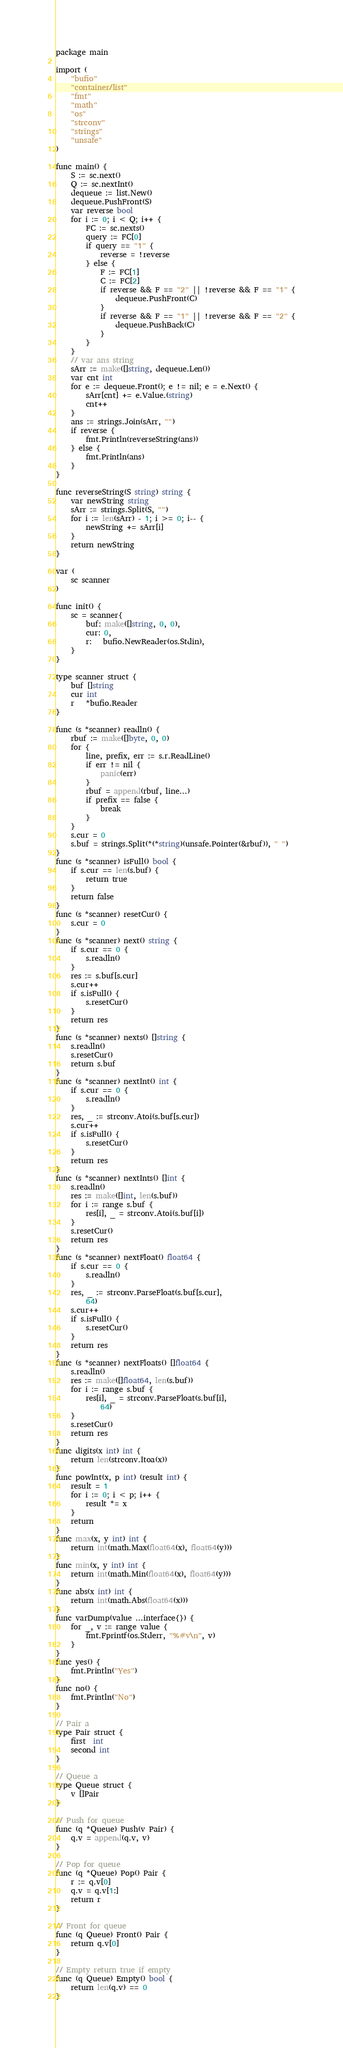<code> <loc_0><loc_0><loc_500><loc_500><_Go_>package main

import (
	"bufio"
	"container/list"
	"fmt"
	"math"
	"os"
	"strconv"
	"strings"
	"unsafe"
)

func main() {
	S := sc.next()
	Q := sc.nextInt()
	dequeue := list.New()
	dequeue.PushFront(S)
	var reverse bool
	for i := 0; i < Q; i++ {
		FC := sc.nexts()
		query := FC[0]
		if query == "1" {
			reverse = !reverse
		} else {
			F := FC[1]
			C := FC[2]
			if reverse && F == "2" || !reverse && F == "1" {
				dequeue.PushFront(C)
			}
			if reverse && F == "1" || !reverse && F == "2" {
				dequeue.PushBack(C)
			}
		}
	}
	// var ans string
	sArr := make([]string, dequeue.Len())
	var cnt int
	for e := dequeue.Front(); e != nil; e = e.Next() {
		sArr[cnt] += e.Value.(string)
		cnt++
	}
	ans := strings.Join(sArr, "")
	if reverse {
		fmt.Println(reverseString(ans))
	} else {
		fmt.Println(ans)
	}
}

func reverseString(S string) string {
	var newString string
	sArr := strings.Split(S, "")
	for i := len(sArr) - 1; i >= 0; i-- {
		newString += sArr[i]
	}
	return newString
}

var (
	sc scanner
)

func init() {
	sc = scanner{
		buf: make([]string, 0, 0),
		cur: 0,
		r:   bufio.NewReader(os.Stdin),
	}
}

type scanner struct {
	buf []string
	cur int
	r   *bufio.Reader
}

func (s *scanner) readln() {
	rbuf := make([]byte, 0, 0)
	for {
		line, prefix, err := s.r.ReadLine()
		if err != nil {
			panic(err)
		}
		rbuf = append(rbuf, line...)
		if prefix == false {
			break
		}
	}
	s.cur = 0
	s.buf = strings.Split(*(*string)(unsafe.Pointer(&rbuf)), " ")
}
func (s *scanner) isFull() bool {
	if s.cur == len(s.buf) {
		return true
	}
	return false
}
func (s *scanner) resetCur() {
	s.cur = 0
}
func (s *scanner) next() string {
	if s.cur == 0 {
		s.readln()
	}
	res := s.buf[s.cur]
	s.cur++
	if s.isFull() {
		s.resetCur()
	}
	return res
}
func (s *scanner) nexts() []string {
	s.readln()
	s.resetCur()
	return s.buf
}
func (s *scanner) nextInt() int {
	if s.cur == 0 {
		s.readln()
	}
	res, _ := strconv.Atoi(s.buf[s.cur])
	s.cur++
	if s.isFull() {
		s.resetCur()
	}
	return res
}
func (s *scanner) nextInts() []int {
	s.readln()
	res := make([]int, len(s.buf))
	for i := range s.buf {
		res[i], _ = strconv.Atoi(s.buf[i])
	}
	s.resetCur()
	return res
}
func (s *scanner) nextFloat() float64 {
	if s.cur == 0 {
		s.readln()
	}
	res, _ := strconv.ParseFloat(s.buf[s.cur],
		64)
	s.cur++
	if s.isFull() {
		s.resetCur()
	}
	return res
}
func (s *scanner) nextFloats() []float64 {
	s.readln()
	res := make([]float64, len(s.buf))
	for i := range s.buf {
		res[i], _ = strconv.ParseFloat(s.buf[i],
			64)
	}
	s.resetCur()
	return res
}
func digits(x int) int {
	return len(strconv.Itoa(x))
}
func powInt(x, p int) (result int) {
	result = 1
	for i := 0; i < p; i++ {
		result *= x
	}
	return
}
func max(x, y int) int {
	return int(math.Max(float64(x), float64(y)))
}
func min(x, y int) int {
	return int(math.Min(float64(x), float64(y)))
}
func abs(x int) int {
	return int(math.Abs(float64(x)))
}
func varDump(value ...interface{}) {
	for _, v := range value {
		fmt.Fprintf(os.Stderr, "%#v\n", v)
	}
}
func yes() {
	fmt.Println("Yes")
}
func no() {
	fmt.Println("No")
}

// Pair a
type Pair struct {
	first  int
	second int
}

// Queue a
type Queue struct {
	v []Pair
}

// Push for queue
func (q *Queue) Push(v Pair) {
	q.v = append(q.v, v)
}

// Pop for queue
func (q *Queue) Pop() Pair {
	r := q.v[0]
	q.v = q.v[1:]
	return r
}

// Front for queue
func (q Queue) Front() Pair {
	return q.v[0]
}

// Empty return true if empty
func (q Queue) Empty() bool {
	return len(q.v) == 0
}
</code> 